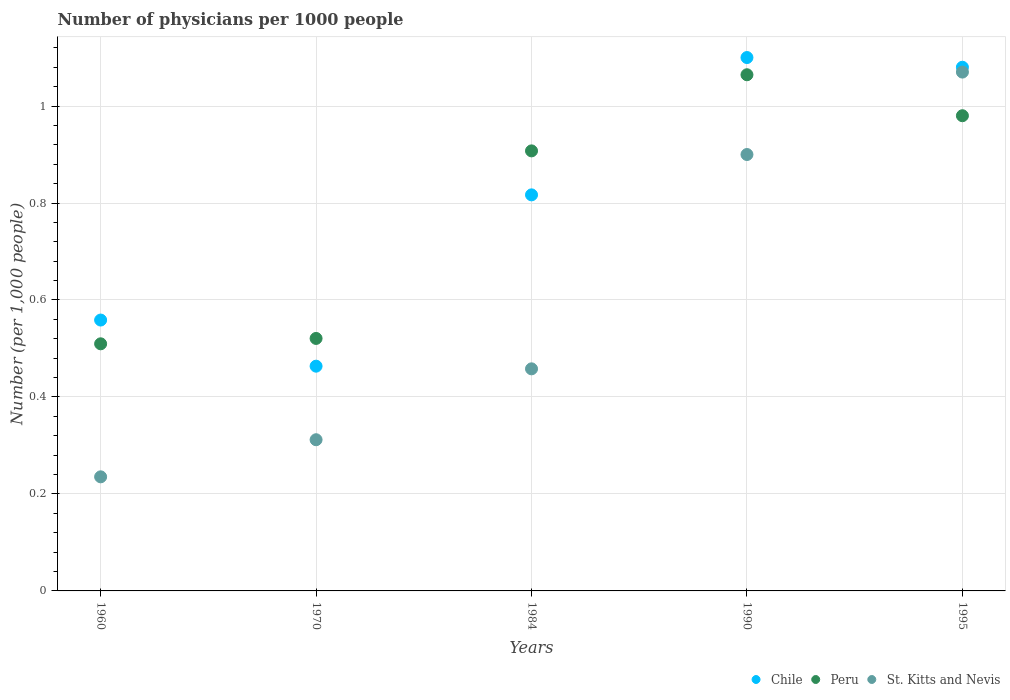How many different coloured dotlines are there?
Ensure brevity in your answer.  3. What is the number of physicians in Peru in 1990?
Your answer should be compact. 1.06. Across all years, what is the maximum number of physicians in St. Kitts and Nevis?
Give a very brief answer. 1.07. Across all years, what is the minimum number of physicians in Peru?
Offer a very short reply. 0.51. What is the total number of physicians in Chile in the graph?
Provide a succinct answer. 4.02. What is the difference between the number of physicians in Peru in 1984 and that in 1990?
Keep it short and to the point. -0.16. What is the difference between the number of physicians in Peru in 1995 and the number of physicians in St. Kitts and Nevis in 1970?
Your response must be concise. 0.67. What is the average number of physicians in Peru per year?
Offer a terse response. 0.8. In the year 1990, what is the difference between the number of physicians in St. Kitts and Nevis and number of physicians in Peru?
Your answer should be very brief. -0.16. In how many years, is the number of physicians in Peru greater than 0.32?
Keep it short and to the point. 5. What is the ratio of the number of physicians in Chile in 1960 to that in 1990?
Your answer should be very brief. 0.51. Is the difference between the number of physicians in St. Kitts and Nevis in 1984 and 1995 greater than the difference between the number of physicians in Peru in 1984 and 1995?
Give a very brief answer. No. What is the difference between the highest and the second highest number of physicians in Chile?
Make the answer very short. 0.02. What is the difference between the highest and the lowest number of physicians in St. Kitts and Nevis?
Your answer should be compact. 0.83. Is the sum of the number of physicians in Chile in 1960 and 1984 greater than the maximum number of physicians in St. Kitts and Nevis across all years?
Ensure brevity in your answer.  Yes. Is it the case that in every year, the sum of the number of physicians in St. Kitts and Nevis and number of physicians in Peru  is greater than the number of physicians in Chile?
Make the answer very short. Yes. Is the number of physicians in St. Kitts and Nevis strictly greater than the number of physicians in Peru over the years?
Ensure brevity in your answer.  No. How many dotlines are there?
Your response must be concise. 3. What is the difference between two consecutive major ticks on the Y-axis?
Make the answer very short. 0.2. Are the values on the major ticks of Y-axis written in scientific E-notation?
Your answer should be compact. No. Does the graph contain any zero values?
Your answer should be compact. No. Does the graph contain grids?
Your answer should be very brief. Yes. What is the title of the graph?
Provide a succinct answer. Number of physicians per 1000 people. What is the label or title of the X-axis?
Ensure brevity in your answer.  Years. What is the label or title of the Y-axis?
Offer a very short reply. Number (per 1,0 people). What is the Number (per 1,000 people) in Chile in 1960?
Give a very brief answer. 0.56. What is the Number (per 1,000 people) in Peru in 1960?
Provide a succinct answer. 0.51. What is the Number (per 1,000 people) of St. Kitts and Nevis in 1960?
Ensure brevity in your answer.  0.24. What is the Number (per 1,000 people) in Chile in 1970?
Make the answer very short. 0.46. What is the Number (per 1,000 people) of Peru in 1970?
Make the answer very short. 0.52. What is the Number (per 1,000 people) in St. Kitts and Nevis in 1970?
Keep it short and to the point. 0.31. What is the Number (per 1,000 people) in Chile in 1984?
Offer a very short reply. 0.82. What is the Number (per 1,000 people) in Peru in 1984?
Provide a succinct answer. 0.91. What is the Number (per 1,000 people) in St. Kitts and Nevis in 1984?
Offer a terse response. 0.46. What is the Number (per 1,000 people) in Chile in 1990?
Your answer should be very brief. 1.1. What is the Number (per 1,000 people) in Peru in 1990?
Your answer should be compact. 1.06. What is the Number (per 1,000 people) in St. Kitts and Nevis in 1990?
Provide a short and direct response. 0.9. What is the Number (per 1,000 people) of Peru in 1995?
Keep it short and to the point. 0.98. What is the Number (per 1,000 people) in St. Kitts and Nevis in 1995?
Make the answer very short. 1.07. Across all years, what is the maximum Number (per 1,000 people) of Chile?
Make the answer very short. 1.1. Across all years, what is the maximum Number (per 1,000 people) in Peru?
Keep it short and to the point. 1.06. Across all years, what is the maximum Number (per 1,000 people) of St. Kitts and Nevis?
Provide a short and direct response. 1.07. Across all years, what is the minimum Number (per 1,000 people) of Chile?
Your answer should be very brief. 0.46. Across all years, what is the minimum Number (per 1,000 people) in Peru?
Give a very brief answer. 0.51. Across all years, what is the minimum Number (per 1,000 people) of St. Kitts and Nevis?
Your answer should be very brief. 0.24. What is the total Number (per 1,000 people) of Chile in the graph?
Give a very brief answer. 4.02. What is the total Number (per 1,000 people) of Peru in the graph?
Keep it short and to the point. 3.98. What is the total Number (per 1,000 people) in St. Kitts and Nevis in the graph?
Your answer should be compact. 2.98. What is the difference between the Number (per 1,000 people) in Chile in 1960 and that in 1970?
Offer a very short reply. 0.1. What is the difference between the Number (per 1,000 people) of Peru in 1960 and that in 1970?
Provide a short and direct response. -0.01. What is the difference between the Number (per 1,000 people) of St. Kitts and Nevis in 1960 and that in 1970?
Your answer should be very brief. -0.08. What is the difference between the Number (per 1,000 people) in Chile in 1960 and that in 1984?
Offer a terse response. -0.26. What is the difference between the Number (per 1,000 people) in Peru in 1960 and that in 1984?
Keep it short and to the point. -0.4. What is the difference between the Number (per 1,000 people) in St. Kitts and Nevis in 1960 and that in 1984?
Keep it short and to the point. -0.22. What is the difference between the Number (per 1,000 people) of Chile in 1960 and that in 1990?
Provide a short and direct response. -0.54. What is the difference between the Number (per 1,000 people) in Peru in 1960 and that in 1990?
Provide a succinct answer. -0.55. What is the difference between the Number (per 1,000 people) in St. Kitts and Nevis in 1960 and that in 1990?
Provide a succinct answer. -0.66. What is the difference between the Number (per 1,000 people) of Chile in 1960 and that in 1995?
Give a very brief answer. -0.52. What is the difference between the Number (per 1,000 people) of Peru in 1960 and that in 1995?
Your response must be concise. -0.47. What is the difference between the Number (per 1,000 people) of St. Kitts and Nevis in 1960 and that in 1995?
Offer a terse response. -0.83. What is the difference between the Number (per 1,000 people) of Chile in 1970 and that in 1984?
Provide a short and direct response. -0.35. What is the difference between the Number (per 1,000 people) of Peru in 1970 and that in 1984?
Your answer should be compact. -0.39. What is the difference between the Number (per 1,000 people) in St. Kitts and Nevis in 1970 and that in 1984?
Your answer should be very brief. -0.15. What is the difference between the Number (per 1,000 people) of Chile in 1970 and that in 1990?
Provide a succinct answer. -0.64. What is the difference between the Number (per 1,000 people) in Peru in 1970 and that in 1990?
Ensure brevity in your answer.  -0.54. What is the difference between the Number (per 1,000 people) in St. Kitts and Nevis in 1970 and that in 1990?
Provide a succinct answer. -0.59. What is the difference between the Number (per 1,000 people) of Chile in 1970 and that in 1995?
Your response must be concise. -0.62. What is the difference between the Number (per 1,000 people) in Peru in 1970 and that in 1995?
Offer a terse response. -0.46. What is the difference between the Number (per 1,000 people) in St. Kitts and Nevis in 1970 and that in 1995?
Keep it short and to the point. -0.76. What is the difference between the Number (per 1,000 people) in Chile in 1984 and that in 1990?
Offer a terse response. -0.28. What is the difference between the Number (per 1,000 people) in Peru in 1984 and that in 1990?
Make the answer very short. -0.16. What is the difference between the Number (per 1,000 people) in St. Kitts and Nevis in 1984 and that in 1990?
Provide a short and direct response. -0.44. What is the difference between the Number (per 1,000 people) in Chile in 1984 and that in 1995?
Give a very brief answer. -0.26. What is the difference between the Number (per 1,000 people) in Peru in 1984 and that in 1995?
Ensure brevity in your answer.  -0.07. What is the difference between the Number (per 1,000 people) in St. Kitts and Nevis in 1984 and that in 1995?
Make the answer very short. -0.61. What is the difference between the Number (per 1,000 people) in Chile in 1990 and that in 1995?
Your answer should be very brief. 0.02. What is the difference between the Number (per 1,000 people) of Peru in 1990 and that in 1995?
Offer a terse response. 0.08. What is the difference between the Number (per 1,000 people) of St. Kitts and Nevis in 1990 and that in 1995?
Your answer should be compact. -0.17. What is the difference between the Number (per 1,000 people) of Chile in 1960 and the Number (per 1,000 people) of Peru in 1970?
Your answer should be compact. 0.04. What is the difference between the Number (per 1,000 people) of Chile in 1960 and the Number (per 1,000 people) of St. Kitts and Nevis in 1970?
Offer a terse response. 0.25. What is the difference between the Number (per 1,000 people) of Peru in 1960 and the Number (per 1,000 people) of St. Kitts and Nevis in 1970?
Provide a succinct answer. 0.2. What is the difference between the Number (per 1,000 people) in Chile in 1960 and the Number (per 1,000 people) in Peru in 1984?
Keep it short and to the point. -0.35. What is the difference between the Number (per 1,000 people) in Chile in 1960 and the Number (per 1,000 people) in St. Kitts and Nevis in 1984?
Give a very brief answer. 0.1. What is the difference between the Number (per 1,000 people) in Peru in 1960 and the Number (per 1,000 people) in St. Kitts and Nevis in 1984?
Your answer should be very brief. 0.05. What is the difference between the Number (per 1,000 people) of Chile in 1960 and the Number (per 1,000 people) of Peru in 1990?
Your answer should be compact. -0.51. What is the difference between the Number (per 1,000 people) in Chile in 1960 and the Number (per 1,000 people) in St. Kitts and Nevis in 1990?
Keep it short and to the point. -0.34. What is the difference between the Number (per 1,000 people) of Peru in 1960 and the Number (per 1,000 people) of St. Kitts and Nevis in 1990?
Provide a succinct answer. -0.39. What is the difference between the Number (per 1,000 people) in Chile in 1960 and the Number (per 1,000 people) in Peru in 1995?
Your response must be concise. -0.42. What is the difference between the Number (per 1,000 people) of Chile in 1960 and the Number (per 1,000 people) of St. Kitts and Nevis in 1995?
Offer a very short reply. -0.51. What is the difference between the Number (per 1,000 people) of Peru in 1960 and the Number (per 1,000 people) of St. Kitts and Nevis in 1995?
Your answer should be very brief. -0.56. What is the difference between the Number (per 1,000 people) in Chile in 1970 and the Number (per 1,000 people) in Peru in 1984?
Offer a terse response. -0.44. What is the difference between the Number (per 1,000 people) in Chile in 1970 and the Number (per 1,000 people) in St. Kitts and Nevis in 1984?
Offer a very short reply. 0.01. What is the difference between the Number (per 1,000 people) of Peru in 1970 and the Number (per 1,000 people) of St. Kitts and Nevis in 1984?
Make the answer very short. 0.06. What is the difference between the Number (per 1,000 people) of Chile in 1970 and the Number (per 1,000 people) of Peru in 1990?
Offer a terse response. -0.6. What is the difference between the Number (per 1,000 people) of Chile in 1970 and the Number (per 1,000 people) of St. Kitts and Nevis in 1990?
Give a very brief answer. -0.44. What is the difference between the Number (per 1,000 people) of Peru in 1970 and the Number (per 1,000 people) of St. Kitts and Nevis in 1990?
Provide a succinct answer. -0.38. What is the difference between the Number (per 1,000 people) in Chile in 1970 and the Number (per 1,000 people) in Peru in 1995?
Your answer should be compact. -0.52. What is the difference between the Number (per 1,000 people) of Chile in 1970 and the Number (per 1,000 people) of St. Kitts and Nevis in 1995?
Keep it short and to the point. -0.61. What is the difference between the Number (per 1,000 people) of Peru in 1970 and the Number (per 1,000 people) of St. Kitts and Nevis in 1995?
Provide a short and direct response. -0.55. What is the difference between the Number (per 1,000 people) of Chile in 1984 and the Number (per 1,000 people) of Peru in 1990?
Make the answer very short. -0.25. What is the difference between the Number (per 1,000 people) in Chile in 1984 and the Number (per 1,000 people) in St. Kitts and Nevis in 1990?
Offer a very short reply. -0.08. What is the difference between the Number (per 1,000 people) in Peru in 1984 and the Number (per 1,000 people) in St. Kitts and Nevis in 1990?
Provide a succinct answer. 0.01. What is the difference between the Number (per 1,000 people) of Chile in 1984 and the Number (per 1,000 people) of Peru in 1995?
Give a very brief answer. -0.16. What is the difference between the Number (per 1,000 people) of Chile in 1984 and the Number (per 1,000 people) of St. Kitts and Nevis in 1995?
Give a very brief answer. -0.25. What is the difference between the Number (per 1,000 people) of Peru in 1984 and the Number (per 1,000 people) of St. Kitts and Nevis in 1995?
Keep it short and to the point. -0.16. What is the difference between the Number (per 1,000 people) of Chile in 1990 and the Number (per 1,000 people) of Peru in 1995?
Provide a succinct answer. 0.12. What is the difference between the Number (per 1,000 people) in Peru in 1990 and the Number (per 1,000 people) in St. Kitts and Nevis in 1995?
Your response must be concise. -0.01. What is the average Number (per 1,000 people) of Chile per year?
Offer a very short reply. 0.8. What is the average Number (per 1,000 people) in Peru per year?
Offer a very short reply. 0.8. What is the average Number (per 1,000 people) of St. Kitts and Nevis per year?
Keep it short and to the point. 0.59. In the year 1960, what is the difference between the Number (per 1,000 people) in Chile and Number (per 1,000 people) in Peru?
Keep it short and to the point. 0.05. In the year 1960, what is the difference between the Number (per 1,000 people) of Chile and Number (per 1,000 people) of St. Kitts and Nevis?
Give a very brief answer. 0.32. In the year 1960, what is the difference between the Number (per 1,000 people) of Peru and Number (per 1,000 people) of St. Kitts and Nevis?
Provide a short and direct response. 0.27. In the year 1970, what is the difference between the Number (per 1,000 people) in Chile and Number (per 1,000 people) in Peru?
Your response must be concise. -0.06. In the year 1970, what is the difference between the Number (per 1,000 people) in Chile and Number (per 1,000 people) in St. Kitts and Nevis?
Offer a terse response. 0.15. In the year 1970, what is the difference between the Number (per 1,000 people) in Peru and Number (per 1,000 people) in St. Kitts and Nevis?
Your answer should be very brief. 0.21. In the year 1984, what is the difference between the Number (per 1,000 people) in Chile and Number (per 1,000 people) in Peru?
Your response must be concise. -0.09. In the year 1984, what is the difference between the Number (per 1,000 people) in Chile and Number (per 1,000 people) in St. Kitts and Nevis?
Ensure brevity in your answer.  0.36. In the year 1984, what is the difference between the Number (per 1,000 people) in Peru and Number (per 1,000 people) in St. Kitts and Nevis?
Provide a succinct answer. 0.45. In the year 1990, what is the difference between the Number (per 1,000 people) in Chile and Number (per 1,000 people) in Peru?
Provide a succinct answer. 0.04. In the year 1990, what is the difference between the Number (per 1,000 people) of Peru and Number (per 1,000 people) of St. Kitts and Nevis?
Keep it short and to the point. 0.16. In the year 1995, what is the difference between the Number (per 1,000 people) in Chile and Number (per 1,000 people) in St. Kitts and Nevis?
Give a very brief answer. 0.01. In the year 1995, what is the difference between the Number (per 1,000 people) of Peru and Number (per 1,000 people) of St. Kitts and Nevis?
Provide a short and direct response. -0.09. What is the ratio of the Number (per 1,000 people) in Chile in 1960 to that in 1970?
Keep it short and to the point. 1.21. What is the ratio of the Number (per 1,000 people) of Peru in 1960 to that in 1970?
Your answer should be compact. 0.98. What is the ratio of the Number (per 1,000 people) in St. Kitts and Nevis in 1960 to that in 1970?
Offer a very short reply. 0.75. What is the ratio of the Number (per 1,000 people) in Chile in 1960 to that in 1984?
Make the answer very short. 0.68. What is the ratio of the Number (per 1,000 people) of Peru in 1960 to that in 1984?
Keep it short and to the point. 0.56. What is the ratio of the Number (per 1,000 people) in St. Kitts and Nevis in 1960 to that in 1984?
Keep it short and to the point. 0.51. What is the ratio of the Number (per 1,000 people) of Chile in 1960 to that in 1990?
Keep it short and to the point. 0.51. What is the ratio of the Number (per 1,000 people) in Peru in 1960 to that in 1990?
Offer a very short reply. 0.48. What is the ratio of the Number (per 1,000 people) of St. Kitts and Nevis in 1960 to that in 1990?
Make the answer very short. 0.26. What is the ratio of the Number (per 1,000 people) in Chile in 1960 to that in 1995?
Your answer should be very brief. 0.52. What is the ratio of the Number (per 1,000 people) of Peru in 1960 to that in 1995?
Give a very brief answer. 0.52. What is the ratio of the Number (per 1,000 people) of St. Kitts and Nevis in 1960 to that in 1995?
Give a very brief answer. 0.22. What is the ratio of the Number (per 1,000 people) in Chile in 1970 to that in 1984?
Offer a very short reply. 0.57. What is the ratio of the Number (per 1,000 people) in Peru in 1970 to that in 1984?
Provide a succinct answer. 0.57. What is the ratio of the Number (per 1,000 people) of St. Kitts and Nevis in 1970 to that in 1984?
Your answer should be compact. 0.68. What is the ratio of the Number (per 1,000 people) in Chile in 1970 to that in 1990?
Your answer should be compact. 0.42. What is the ratio of the Number (per 1,000 people) in Peru in 1970 to that in 1990?
Your answer should be very brief. 0.49. What is the ratio of the Number (per 1,000 people) of St. Kitts and Nevis in 1970 to that in 1990?
Make the answer very short. 0.35. What is the ratio of the Number (per 1,000 people) in Chile in 1970 to that in 1995?
Keep it short and to the point. 0.43. What is the ratio of the Number (per 1,000 people) of Peru in 1970 to that in 1995?
Offer a very short reply. 0.53. What is the ratio of the Number (per 1,000 people) of St. Kitts and Nevis in 1970 to that in 1995?
Your response must be concise. 0.29. What is the ratio of the Number (per 1,000 people) in Chile in 1984 to that in 1990?
Keep it short and to the point. 0.74. What is the ratio of the Number (per 1,000 people) in Peru in 1984 to that in 1990?
Your response must be concise. 0.85. What is the ratio of the Number (per 1,000 people) of St. Kitts and Nevis in 1984 to that in 1990?
Provide a succinct answer. 0.51. What is the ratio of the Number (per 1,000 people) of Chile in 1984 to that in 1995?
Keep it short and to the point. 0.76. What is the ratio of the Number (per 1,000 people) of Peru in 1984 to that in 1995?
Offer a terse response. 0.93. What is the ratio of the Number (per 1,000 people) in St. Kitts and Nevis in 1984 to that in 1995?
Keep it short and to the point. 0.43. What is the ratio of the Number (per 1,000 people) in Chile in 1990 to that in 1995?
Your answer should be compact. 1.02. What is the ratio of the Number (per 1,000 people) of Peru in 1990 to that in 1995?
Offer a terse response. 1.09. What is the ratio of the Number (per 1,000 people) in St. Kitts and Nevis in 1990 to that in 1995?
Provide a short and direct response. 0.84. What is the difference between the highest and the second highest Number (per 1,000 people) of Chile?
Keep it short and to the point. 0.02. What is the difference between the highest and the second highest Number (per 1,000 people) of Peru?
Provide a short and direct response. 0.08. What is the difference between the highest and the second highest Number (per 1,000 people) in St. Kitts and Nevis?
Provide a succinct answer. 0.17. What is the difference between the highest and the lowest Number (per 1,000 people) in Chile?
Make the answer very short. 0.64. What is the difference between the highest and the lowest Number (per 1,000 people) in Peru?
Provide a short and direct response. 0.55. What is the difference between the highest and the lowest Number (per 1,000 people) in St. Kitts and Nevis?
Keep it short and to the point. 0.83. 